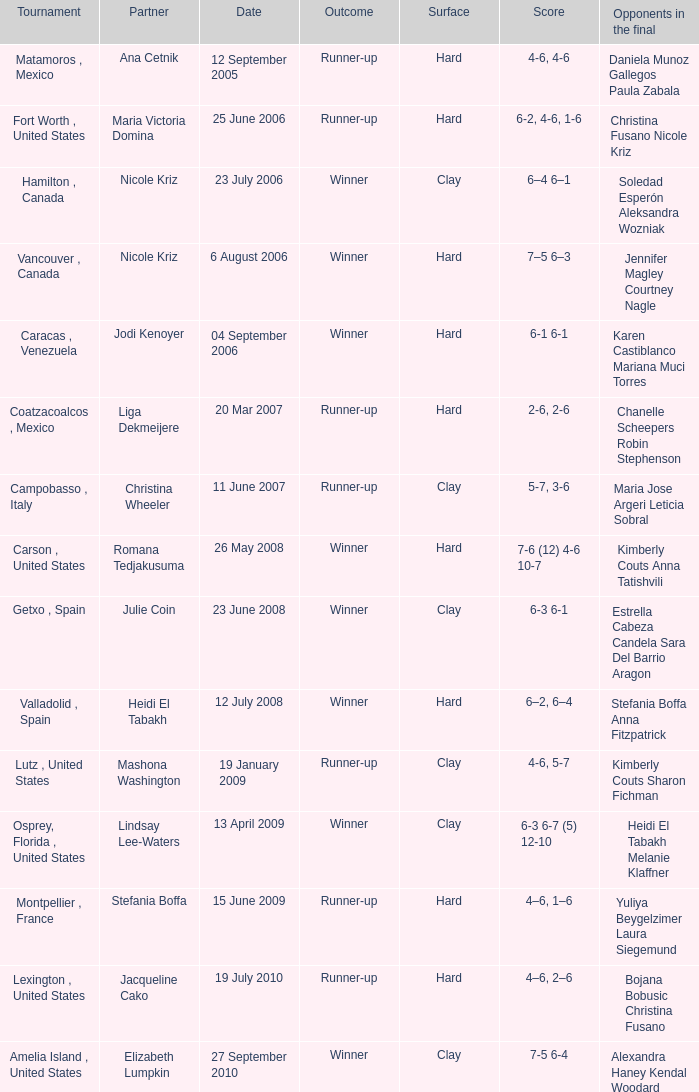What was the date for the match where Tweedie-Yates' partner was jodi kenoyer? 04 September 2006. 